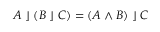Convert formula to latex. <formula><loc_0><loc_0><loc_500><loc_500>A \, \rfloor \, ( B \, \rfloor \, C ) = ( A \wedge B ) \, \rfloor \, C</formula> 